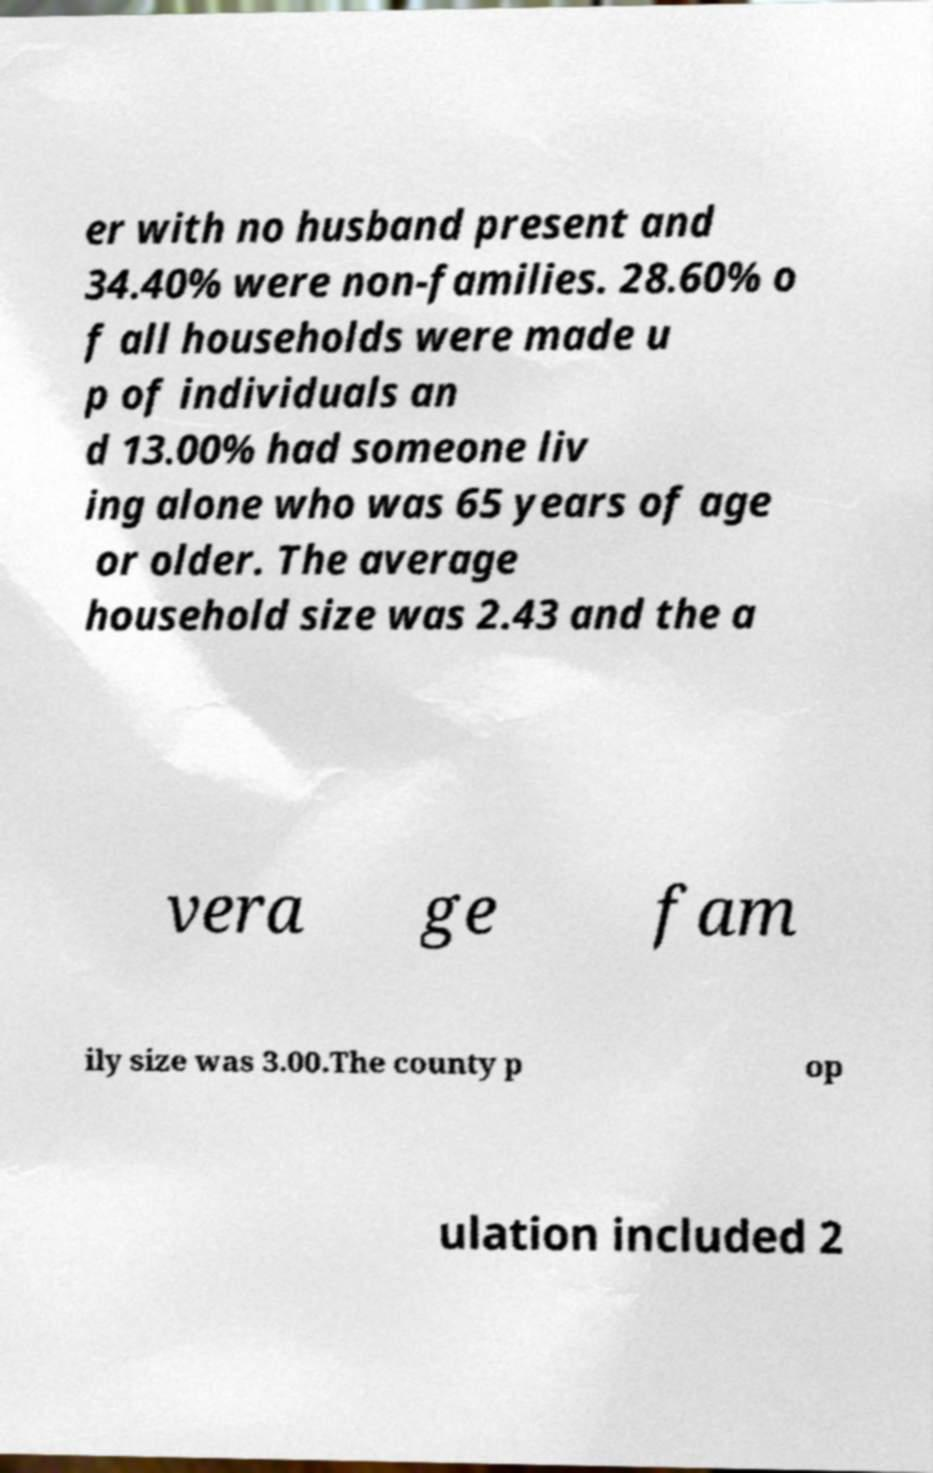I need the written content from this picture converted into text. Can you do that? er with no husband present and 34.40% were non-families. 28.60% o f all households were made u p of individuals an d 13.00% had someone liv ing alone who was 65 years of age or older. The average household size was 2.43 and the a vera ge fam ily size was 3.00.The county p op ulation included 2 